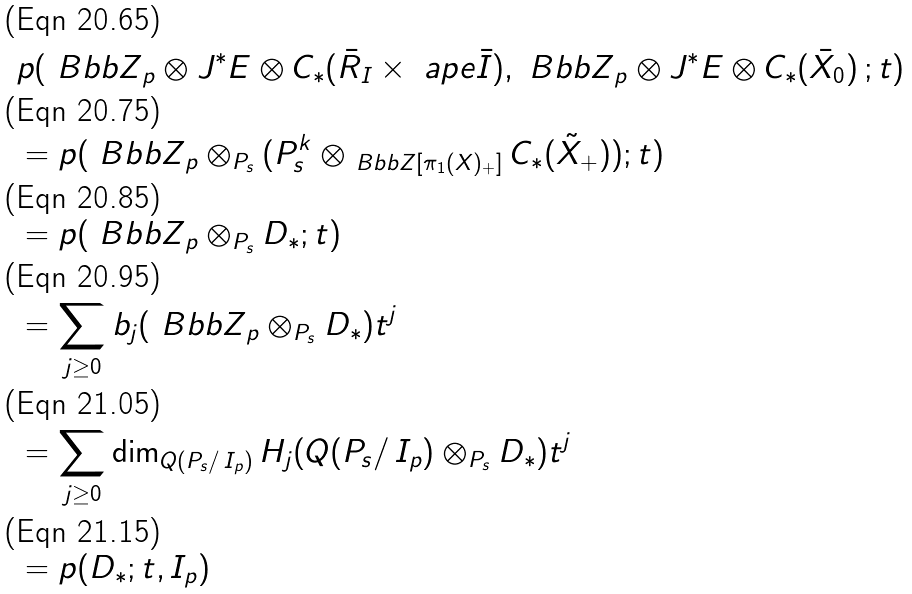Convert formula to latex. <formula><loc_0><loc_0><loc_500><loc_500>& p ( { \ B b b Z } _ { p } \otimes J ^ { * } E \otimes C _ { * } ( \bar { R } _ { I } \times \ a p e \bar { I } ) , { \ B b b Z } _ { p } \otimes J ^ { * } E \otimes C _ { * } ( \bar { X } _ { 0 } ) \, ; t ) \\ & = p ( { \ B b b Z } _ { p } \otimes _ { P _ { s } } ( P ^ { k } _ { s } \otimes _ { { \ B b b Z } [ \pi _ { 1 } ( X ) _ { + } ] } C _ { * } ( \tilde { X } _ { + } ) ) ; t ) \\ & = p ( { \ B b b Z } _ { p } \otimes _ { P _ { s } } D _ { * } ; t ) \\ & = \sum _ { j \geq 0 } b _ { j } ( { \ B b b Z } _ { p } \otimes _ { P _ { s } } D _ { * } ) t ^ { j } \\ & = \sum _ { j \geq 0 } \dim _ { Q ( P _ { s } / \, I _ { p } ) } { H _ { j } ( Q ( P _ { s } / \, I _ { p } ) \otimes _ { P _ { s } } D _ { * } ) } t ^ { j } \\ & = p ( D _ { * } ; t , I _ { p } )</formula> 